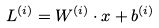Convert formula to latex. <formula><loc_0><loc_0><loc_500><loc_500>& L ^ { ( i ) } = W ^ { ( i ) } \cdot x + b ^ { ( i ) }</formula> 